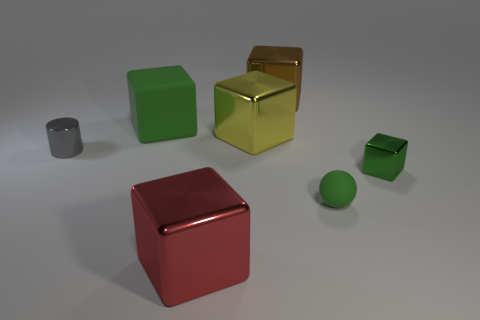Add 3 brown metal cubes. How many objects exist? 10 Subtract all brown metallic cubes. How many cubes are left? 4 Subtract all yellow cylinders. How many brown cubes are left? 1 Subtract all yellow cubes. How many cubes are left? 4 Subtract all balls. How many objects are left? 6 Subtract 1 cylinders. How many cylinders are left? 0 Subtract all yellow blocks. Subtract all red spheres. How many blocks are left? 4 Subtract all tiny cubes. Subtract all green matte blocks. How many objects are left? 5 Add 5 big brown cubes. How many big brown cubes are left? 6 Add 4 brown matte cylinders. How many brown matte cylinders exist? 4 